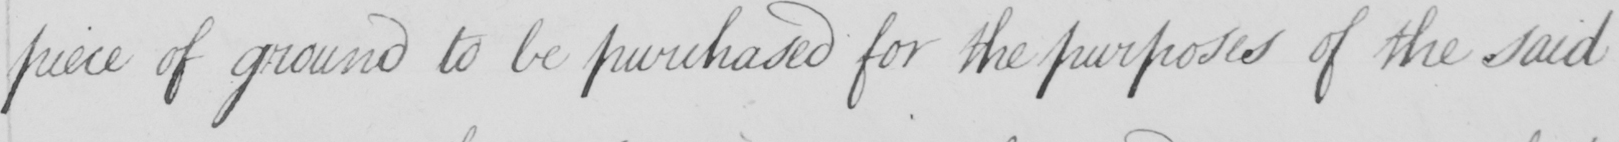What does this handwritten line say? piece of ground to be purchased for the purposes of the said 